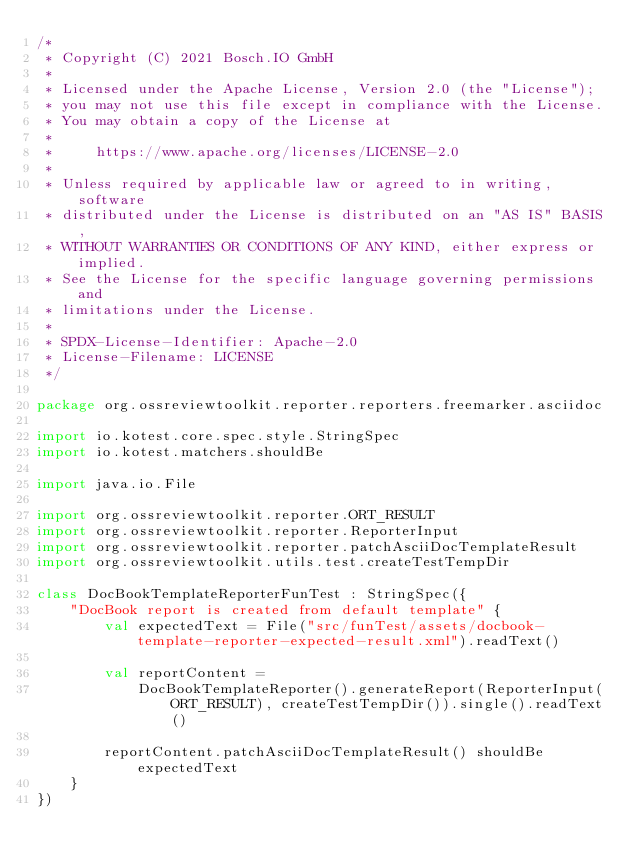<code> <loc_0><loc_0><loc_500><loc_500><_Kotlin_>/*
 * Copyright (C) 2021 Bosch.IO GmbH
 *
 * Licensed under the Apache License, Version 2.0 (the "License");
 * you may not use this file except in compliance with the License.
 * You may obtain a copy of the License at
 *
 *     https://www.apache.org/licenses/LICENSE-2.0
 *
 * Unless required by applicable law or agreed to in writing, software
 * distributed under the License is distributed on an "AS IS" BASIS,
 * WITHOUT WARRANTIES OR CONDITIONS OF ANY KIND, either express or implied.
 * See the License for the specific language governing permissions and
 * limitations under the License.
 *
 * SPDX-License-Identifier: Apache-2.0
 * License-Filename: LICENSE
 */

package org.ossreviewtoolkit.reporter.reporters.freemarker.asciidoc

import io.kotest.core.spec.style.StringSpec
import io.kotest.matchers.shouldBe

import java.io.File

import org.ossreviewtoolkit.reporter.ORT_RESULT
import org.ossreviewtoolkit.reporter.ReporterInput
import org.ossreviewtoolkit.reporter.patchAsciiDocTemplateResult
import org.ossreviewtoolkit.utils.test.createTestTempDir

class DocBookTemplateReporterFunTest : StringSpec({
    "DocBook report is created from default template" {
        val expectedText = File("src/funTest/assets/docbook-template-reporter-expected-result.xml").readText()

        val reportContent =
            DocBookTemplateReporter().generateReport(ReporterInput(ORT_RESULT), createTestTempDir()).single().readText()

        reportContent.patchAsciiDocTemplateResult() shouldBe expectedText
    }
})
</code> 